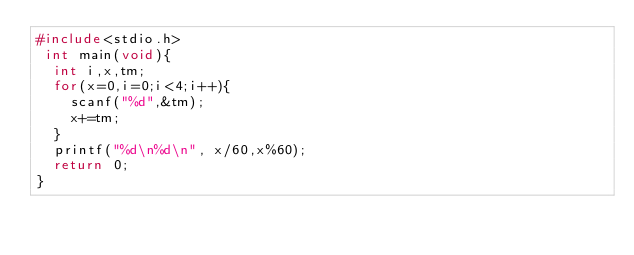Convert code to text. <code><loc_0><loc_0><loc_500><loc_500><_C_>#include<stdio.h>
 int main(void){
  int i,x,tm;
  for(x=0,i=0;i<4;i++){
    scanf("%d",&tm);
    x+=tm;
  }
  printf("%d\n%d\n", x/60,x%60);
  return 0;
}</code> 